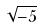<formula> <loc_0><loc_0><loc_500><loc_500>\sqrt { - 5 }</formula> 